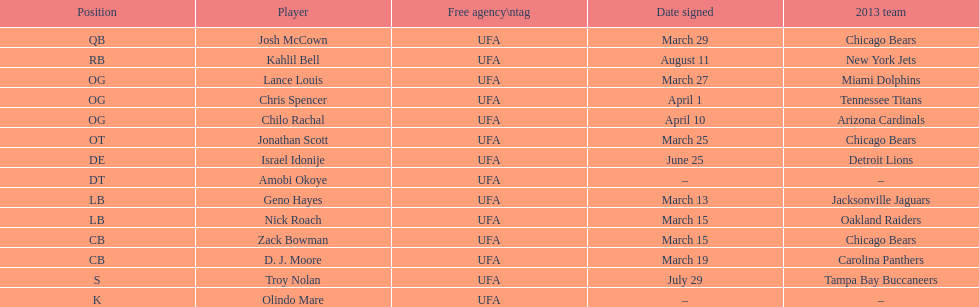I'm looking to parse the entire table for insights. Could you assist me with that? {'header': ['Position', 'Player', 'Free agency\\ntag', 'Date signed', '2013 team'], 'rows': [['QB', 'Josh McCown', 'UFA', 'March 29', 'Chicago Bears'], ['RB', 'Kahlil Bell', 'UFA', 'August 11', 'New York Jets'], ['OG', 'Lance Louis', 'UFA', 'March 27', 'Miami Dolphins'], ['OG', 'Chris Spencer', 'UFA', 'April 1', 'Tennessee Titans'], ['OG', 'Chilo Rachal', 'UFA', 'April 10', 'Arizona Cardinals'], ['OT', 'Jonathan Scott', 'UFA', 'March 25', 'Chicago Bears'], ['DE', 'Israel Idonije', 'UFA', 'June 25', 'Detroit Lions'], ['DT', 'Amobi Okoye', 'UFA', '–', '–'], ['LB', 'Geno Hayes', 'UFA', 'March 13', 'Jacksonville Jaguars'], ['LB', 'Nick Roach', 'UFA', 'March 15', 'Oakland Raiders'], ['CB', 'Zack Bowman', 'UFA', 'March 15', 'Chicago Bears'], ['CB', 'D. J. Moore', 'UFA', 'March 19', 'Carolina Panthers'], ['S', 'Troy Nolan', 'UFA', 'July 29', 'Tampa Bay Buccaneers'], ['K', 'Olindo Mare', 'UFA', '–', '–']]} Family name is also a first name commencing with "n" Troy Nolan. 